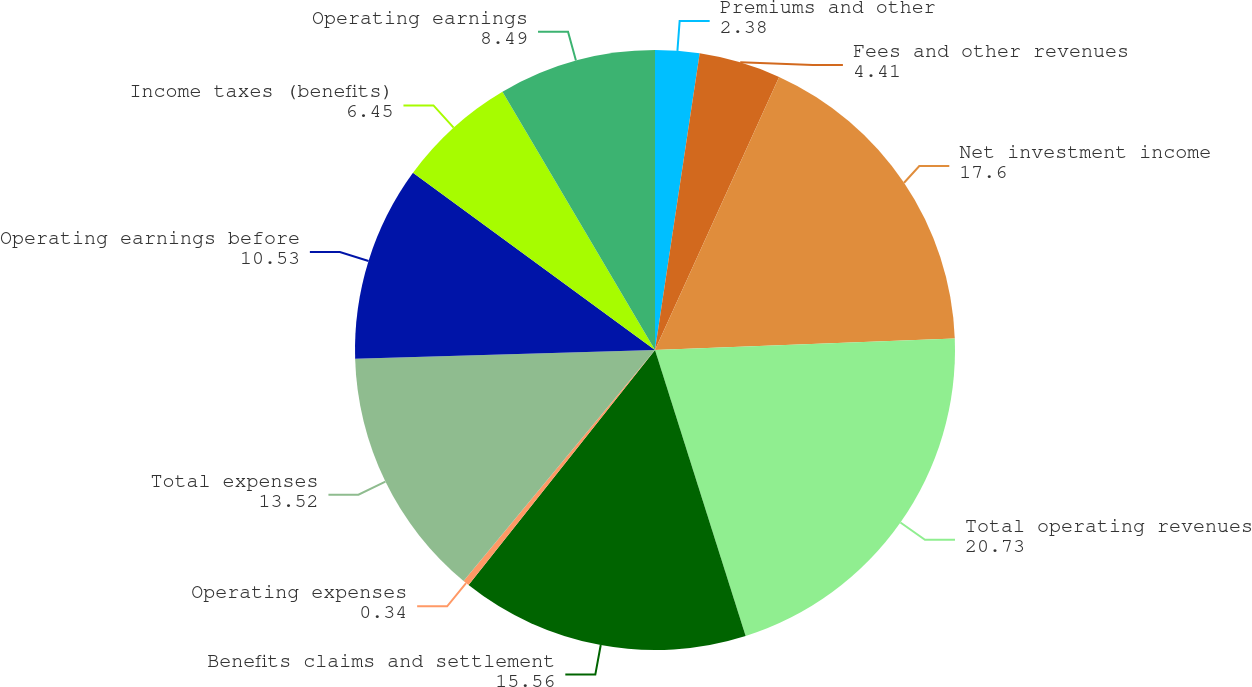<chart> <loc_0><loc_0><loc_500><loc_500><pie_chart><fcel>Premiums and other<fcel>Fees and other revenues<fcel>Net investment income<fcel>Total operating revenues<fcel>Benefits claims and settlement<fcel>Operating expenses<fcel>Total expenses<fcel>Operating earnings before<fcel>Income taxes (benefits)<fcel>Operating earnings<nl><fcel>2.38%<fcel>4.41%<fcel>17.6%<fcel>20.73%<fcel>15.56%<fcel>0.34%<fcel>13.52%<fcel>10.53%<fcel>6.45%<fcel>8.49%<nl></chart> 